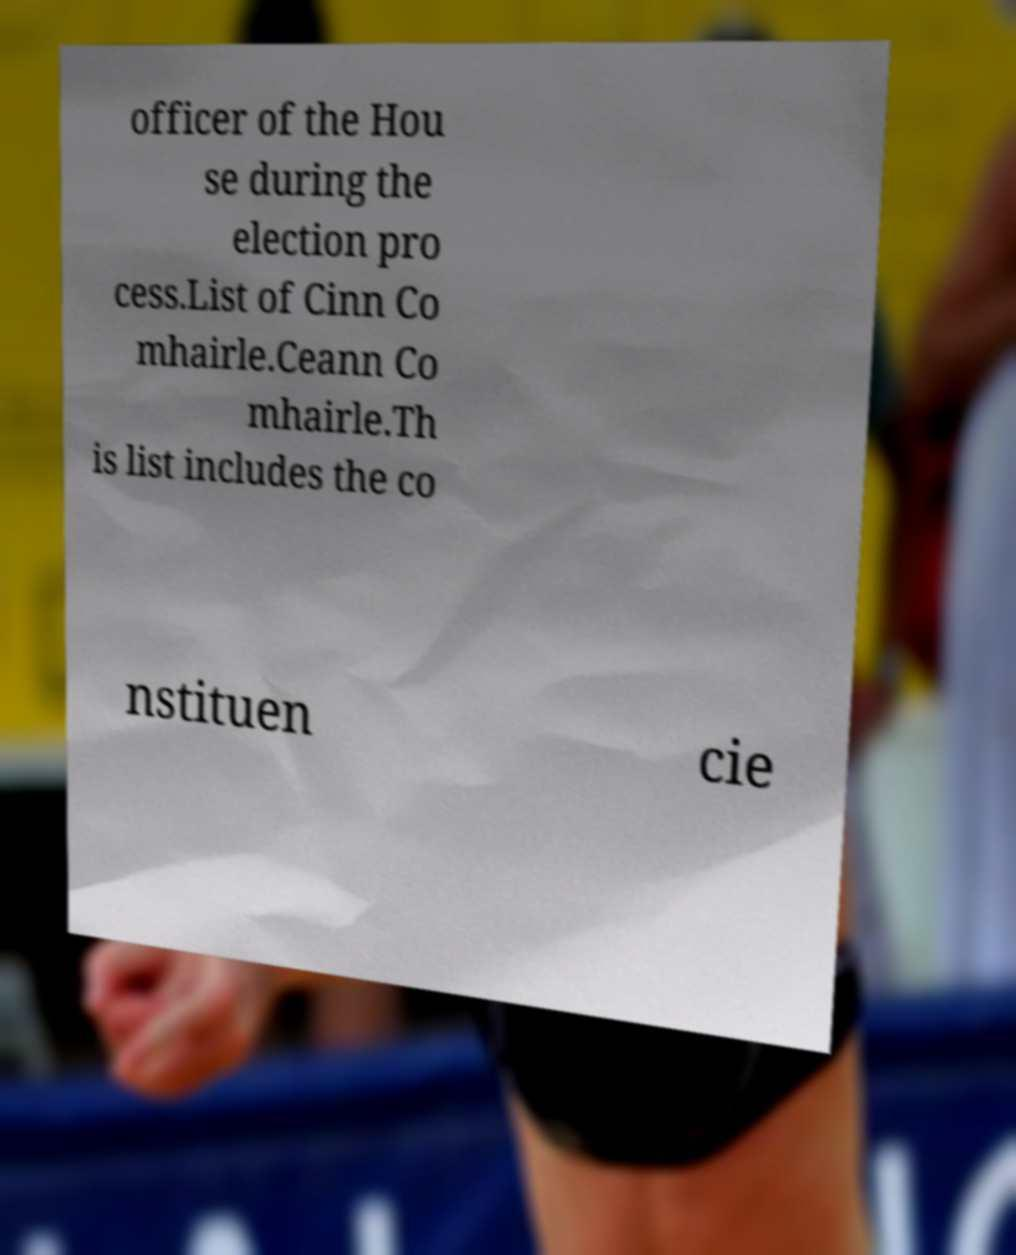Please read and relay the text visible in this image. What does it say? officer of the Hou se during the election pro cess.List of Cinn Co mhairle.Ceann Co mhairle.Th is list includes the co nstituen cie 